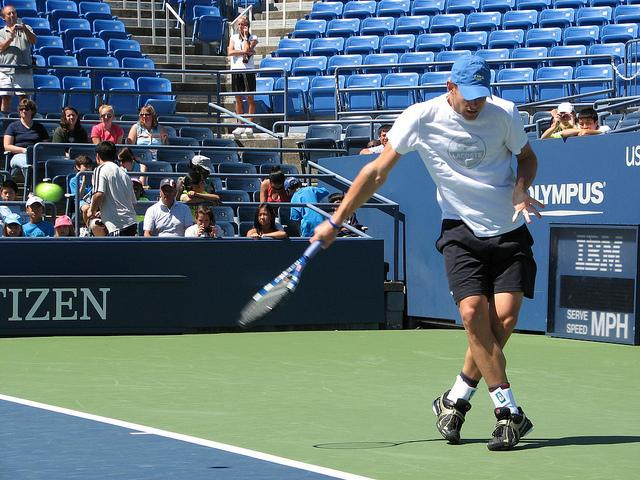What company is sponsoring the speed board? ibm 